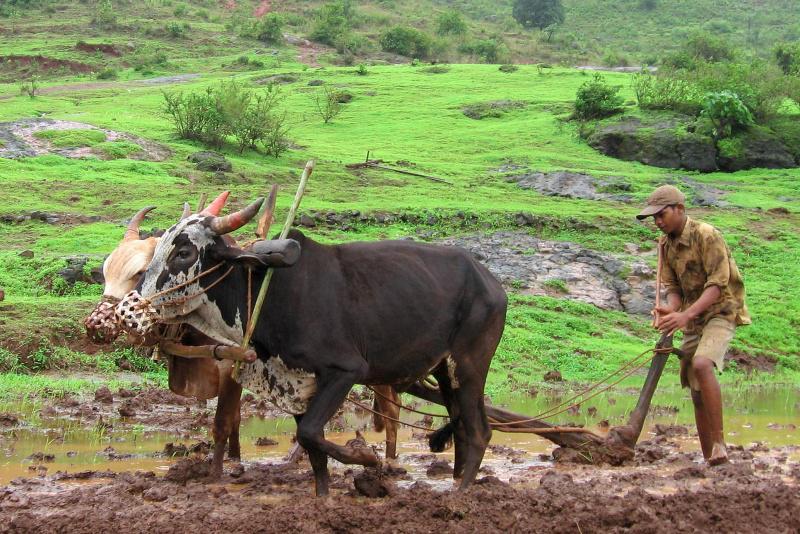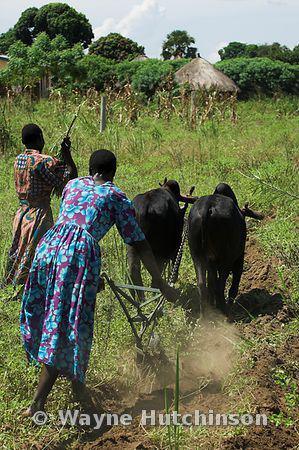The first image is the image on the left, the second image is the image on the right. Analyze the images presented: Is the assertion "The humans are to the right of the cows in the left image." valid? Answer yes or no. Yes. The first image is the image on the left, the second image is the image on the right. For the images shown, is this caption "There are black and brown oxes going right tilting the land as man with a hat follows." true? Answer yes or no. Yes. 